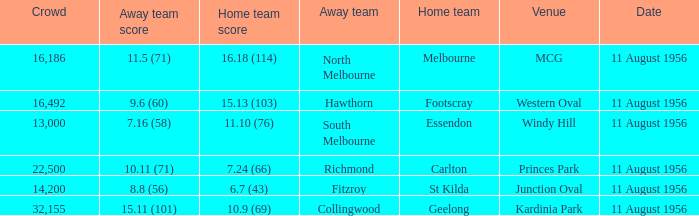What is the home team score for Footscray? 15.13 (103). 